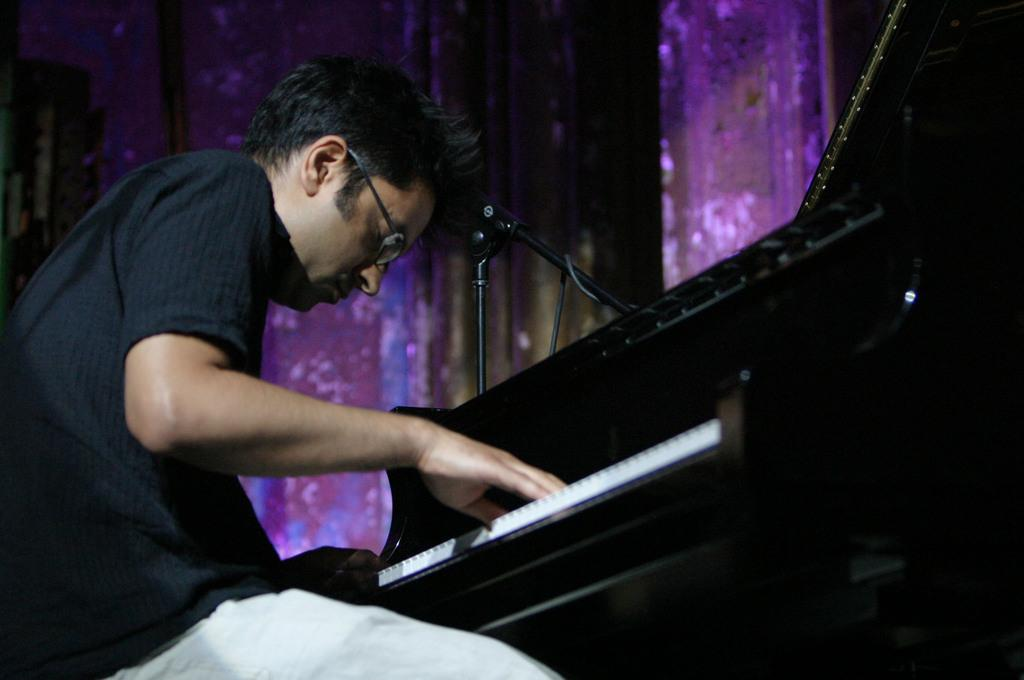What is the man in the image doing? The man is playing the piano in the image. What is the man wearing that helps him see? The man is wearing spectacles in the image. How is the man playing the piano? The man is using his hands to play the piano in the image. What is present near the piano in the image? There is a mic stand on the piano in the image. What can be seen in the background of the image? There is a wall in the background of the image. How many matches are the man using to play the piano in the image? There are no matches present in the image; the man is using his hands to play the piano. What type of sticks is the man holding in the image? There are no sticks visible in the image; the man is using his hands to play the piano. 